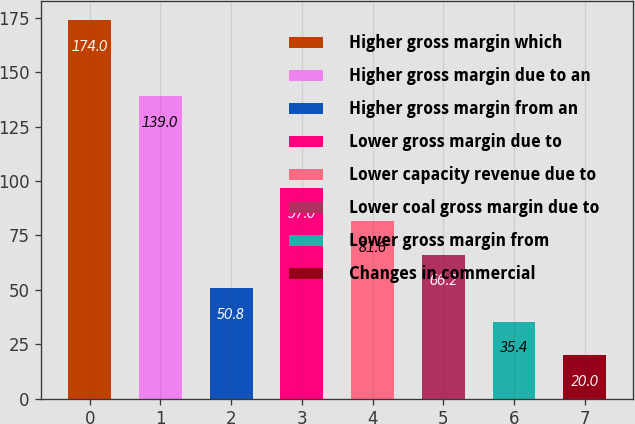<chart> <loc_0><loc_0><loc_500><loc_500><bar_chart><fcel>Higher gross margin which<fcel>Higher gross margin due to an<fcel>Higher gross margin from an<fcel>Lower gross margin due to<fcel>Lower capacity revenue due to<fcel>Lower coal gross margin due to<fcel>Lower gross margin from<fcel>Changes in commercial<nl><fcel>174<fcel>139<fcel>50.8<fcel>97<fcel>81.6<fcel>66.2<fcel>35.4<fcel>20<nl></chart> 